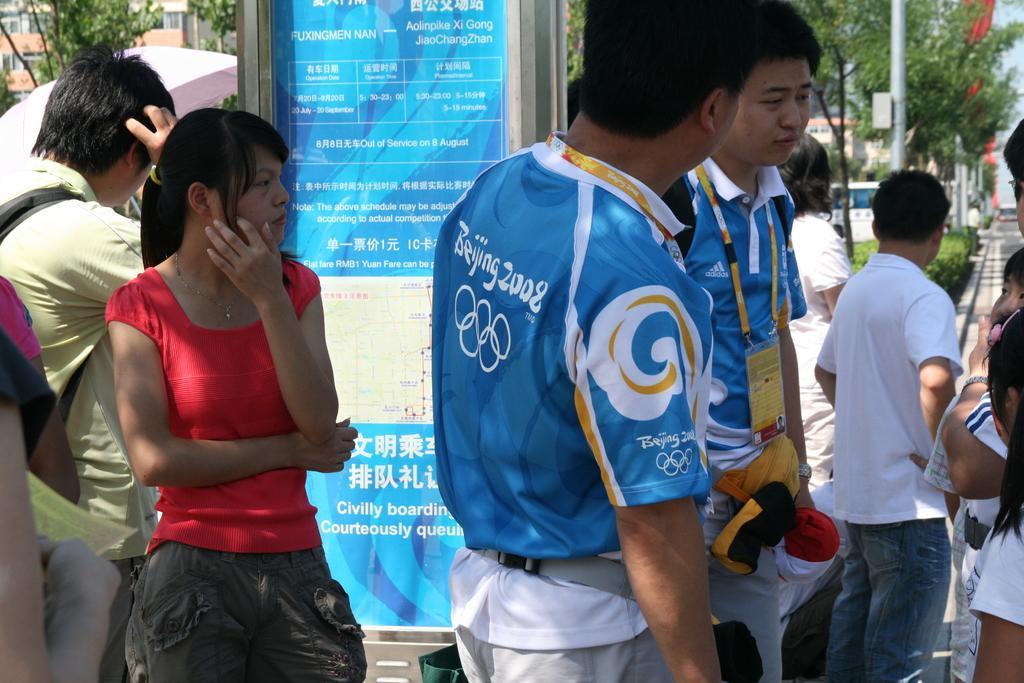How would you summarize this image in a sentence or two? In the center of the image we can see a board. In the background of the image we can see the buildings, trees, poles and some people are standing. On the left side of the image we can see an umbrella. On the right side of the image we can see the road and the vehicle. In the top right corner we can see the sky. 